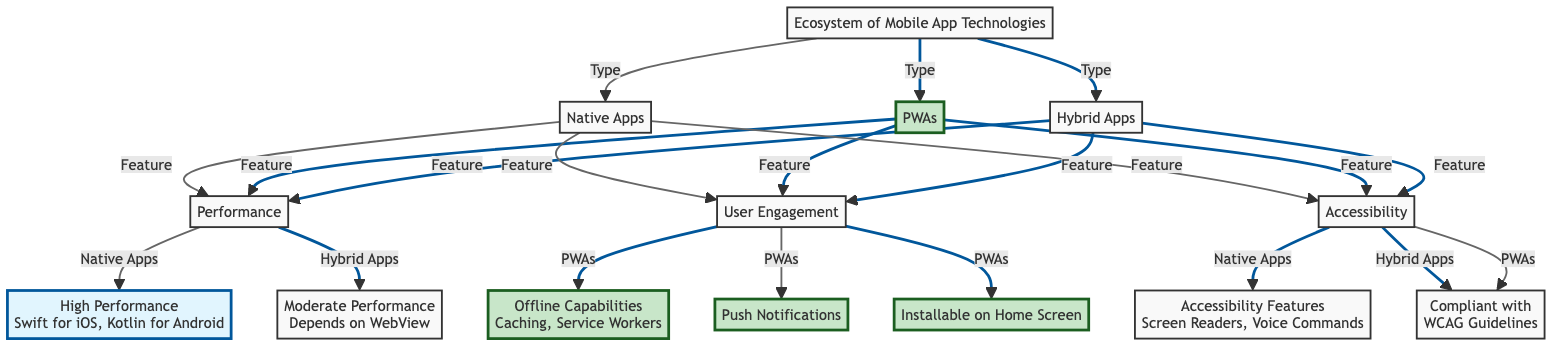What are the three types of mobile app technologies shown in the diagram? The diagram lists three types of mobile app technologies: Native Apps, PWAs, and Hybrid Apps.
Answer: Native Apps, PWAs, and Hybrid Apps Which technology has high performance according to the diagram? Native Apps are identified in the diagram as the technology with high performance.
Answer: Native Apps How many features are listed for PWAs in the diagram? The diagram indicates three distinct features associated with PWAs: Offline Capabilities, Push Notifications, and Installable on Home Screen.
Answer: Three Which type of app relies on WebView for its performance? The diagram specifies that Hybrid Apps depend on WebView for their performance, resulting in moderate performance.
Answer: Hybrid Apps What accessibility features are mentioned for PWAs? The diagram shows that PWAs include compliance with WCAG Guidelines and features such as Screen Readers and Voice Commands.
Answer: Compliance with WCAG Guidelines How does the performance of Hybrid Apps compare to Native Apps? The diagram describes Native Apps as having high performance, while Hybrid Apps are noted for moderate performance due to their dependence on WebView.
Answer: Moderate performance Which nodes are directly linked to Accessibility in the diagram? The diagram links Native Apps, Hybrid Apps, and PWAs directly to Accessibility, indicating they all have related features.
Answer: Native Apps, Hybrid Apps, PWAs What performance capability is unique to PWAs? The unique performance capability for PWAs highlighted in the diagram is Offline Capabilities, including features like Caching and Service Workers.
Answer: Offline Capabilities What feature distinguishes Native Apps in terms of performance? The specific feature that distinguishes Native Apps is their use of Swift for iOS and Kotlin for Android, which contributes to their high performance.
Answer: Swift for iOS, Kotlin for Android 